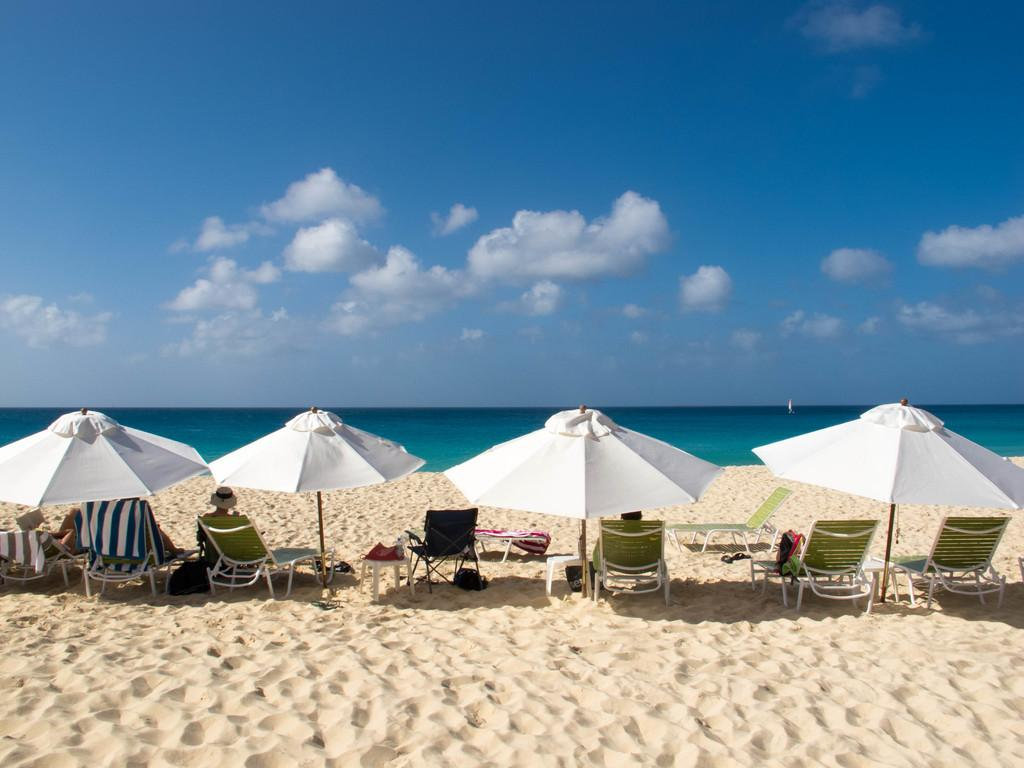What type of location is depicted in the image? There is a beach in the image. What type of seating can be seen on the beach? There are chairs under umbrellas on the beach. What is visible in the background of the image? The sky is visible in the background of the image. What type of structure can be seen on the beach in the image? There is no specific structure mentioned in the provided facts, so we cannot determine if there is a structure on the beach in the image. 